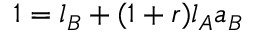Convert formula to latex. <formula><loc_0><loc_0><loc_500><loc_500>1 = l _ { B } + ( 1 + r ) l _ { A } a _ { B }</formula> 